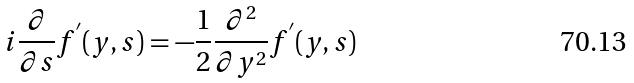<formula> <loc_0><loc_0><loc_500><loc_500>i \frac { \partial } { \partial s } f ^ { ^ { \prime } } ( y , s ) = - \frac { 1 } { 2 } \frac { \partial ^ { 2 } } { \partial y ^ { 2 } } f ^ { ^ { \prime } } ( y , s )</formula> 